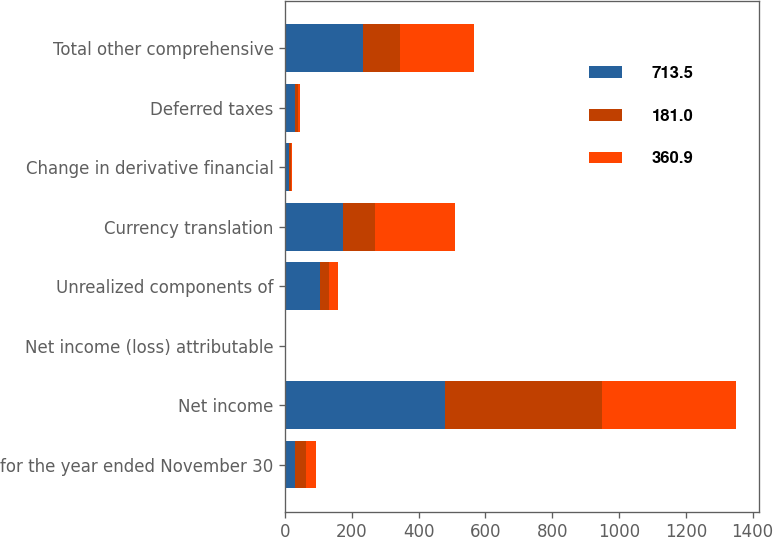<chart> <loc_0><loc_0><loc_500><loc_500><stacked_bar_chart><ecel><fcel>for the year ended November 30<fcel>Net income<fcel>Net income (loss) attributable<fcel>Unrealized components of<fcel>Currency translation<fcel>Change in derivative financial<fcel>Deferred taxes<fcel>Total other comprehensive<nl><fcel>713.5<fcel>30.8<fcel>477.4<fcel>1.6<fcel>103.2<fcel>174.6<fcel>12.5<fcel>30.8<fcel>234.5<nl><fcel>181<fcel>30.8<fcel>472.3<fcel>1.3<fcel>28.5<fcel>94.6<fcel>4.1<fcel>8.9<fcel>110.1<nl><fcel>360.9<fcel>30.8<fcel>401.6<fcel>0.5<fcel>27.4<fcel>239.8<fcel>3.4<fcel>5.3<fcel>221.1<nl></chart> 